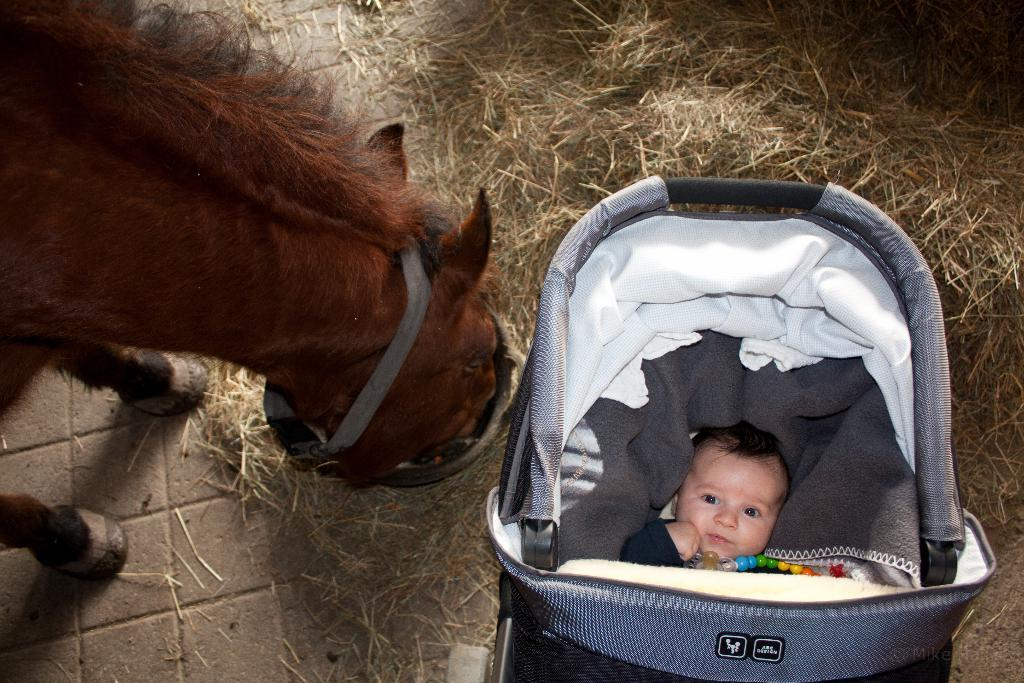What is the main subject in the image? There is a baby in a stroller in the image. What can be seen on the left side of the image? There is a horse on the left side of the image. What is located on the ground in the image? There is a straw stack on the ground in the image. How many screws can be seen on the baby's stroller in the image? There is no mention of screws on the baby's stroller in the image, so it is not possible to determine the number of screws. 